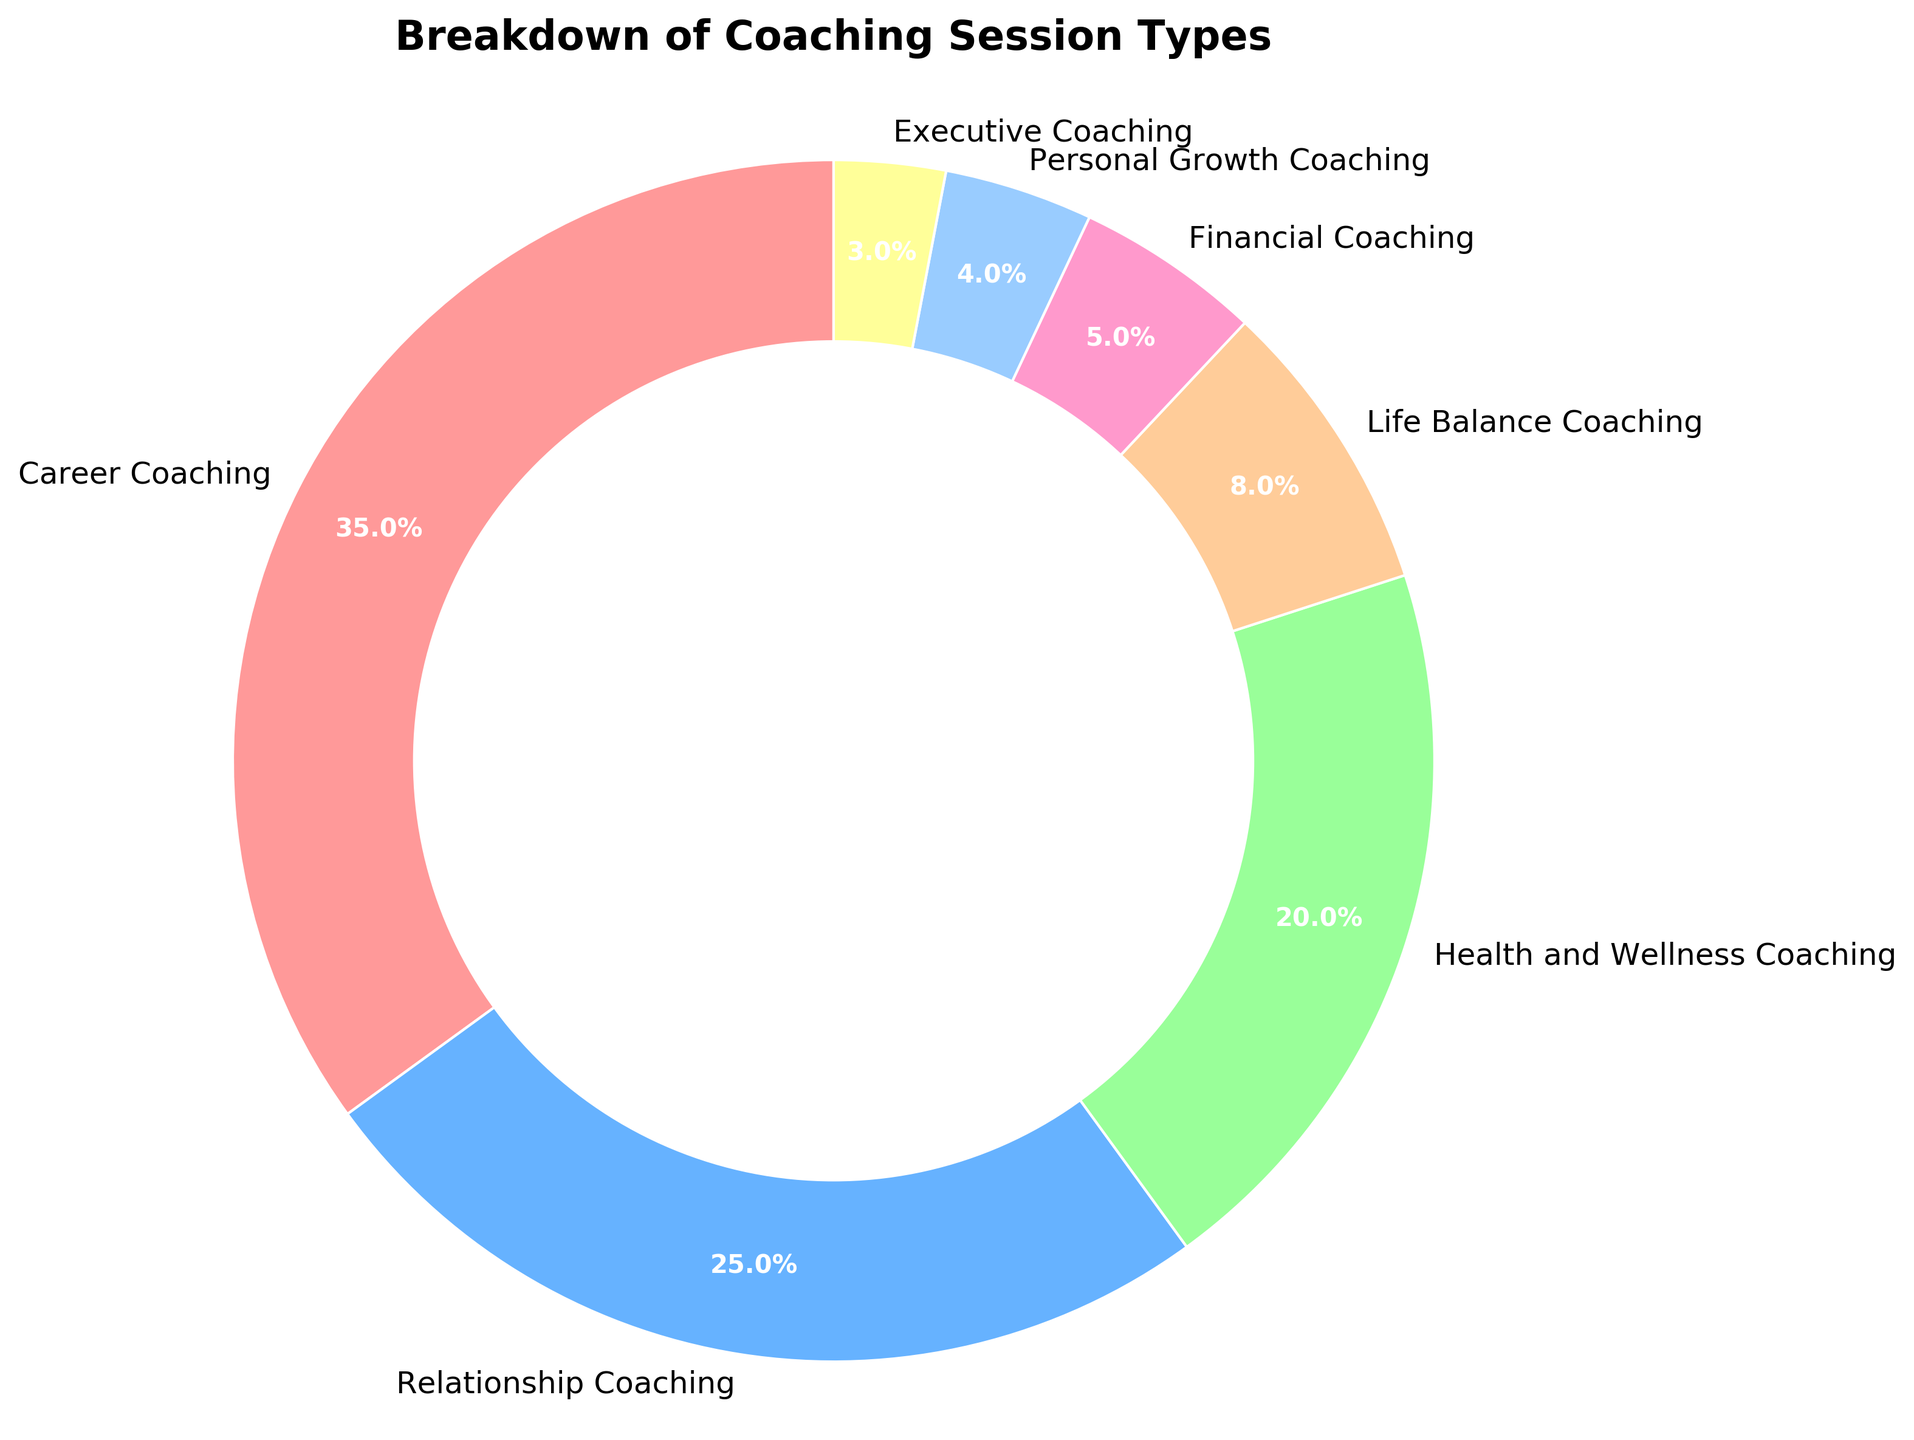What's the largest segment in the pie chart? The largest segment can be identified by the percentage values provided for each session type. "Career Coaching" has the highest percentage at 35%.
Answer: Career Coaching Which segment has a higher percentage, Health and Wellness Coaching or Relationship Coaching? Comparing the percentages of Health and Wellness Coaching (20%) and Relationship Coaching (25%), the latter has a higher value.
Answer: Relationship Coaching What is the combined percentage of Executive Coaching and Personal Growth Coaching? Adding the percentages of Executive Coaching (3%) and Personal Growth Coaching (4%) gives 3% + 4% = 7%.
Answer: 7% How much larger is Career Coaching compared to Executive Coaching in terms of percentage? Subtract the percentage of Executive Coaching (3%) from Career Coaching (35%) to find the difference: 35% - 3% = 32%.
Answer: 32% Which session type has the smallest percentage, and what is it? The smallest percentage value can be identified directly from the chart. "Executive Coaching" has the smallest percentage at 3%.
Answer: Executive Coaching, 3% What is the total percentage of the three smallest segments combined? Adding percentages of the three smallest segments: Executive Coaching (3%), Personal Growth Coaching (4%), and Financial Coaching (5%): 3% + 4% + 5% = 12%.
Answer: 12% If you combine the percentages of Life Balance Coaching and Financial Coaching, how does it compare to the percentage of Health and Wellness Coaching? Combining percentages of Life Balance Coaching (8%) and Financial Coaching (5%) gives 8% + 5% = 13%. Comparing this to Health and Wellness Coaching (20%), 13% is less than 20%.
Answer: Less Which session type might you infer to be most popular and why? The session type with the largest percentage (35%) is likely the most popular, which is Career Coaching.
Answer: Career Coaching How many session types have a percentage equal to or greater than 20%? Identifying session types with percentages ≥ 20%: Career Coaching (35%), Relationship Coaching (25%), and Health and Wellness Coaching (20%). There are 3 such session types.
Answer: 3 What is the total percentage represented by Career Coaching, Relationship Coaching, and Health and Wellness Coaching combined? Adding the percentages of Career Coaching (35%), Relationship Coaching (25%), and Health and Wellness Coaching (20%) gives: 35% + 25% + 20% = 80%.
Answer: 80% 